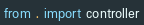Convert code to text. <code><loc_0><loc_0><loc_500><loc_500><_Python_>
from . import controller
</code> 